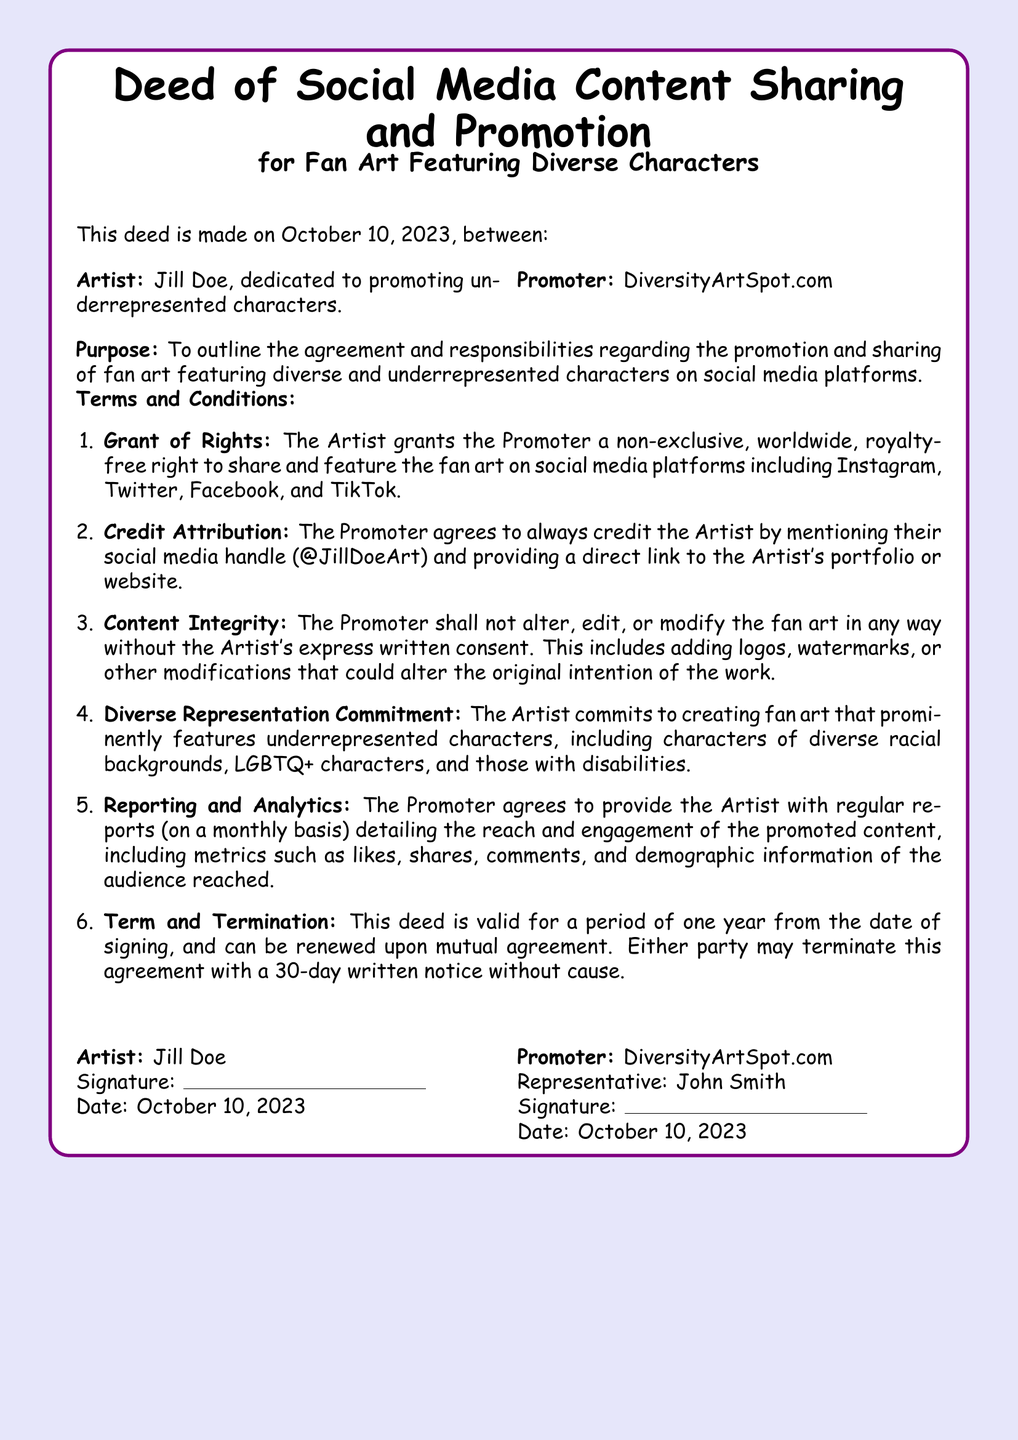What is the date of the deed? The date of the deed is mentioned at the beginning of the document, which is October 10, 2023.
Answer: October 10, 2023 Who is the artist? The artist's name is listed in the document, which is Jill Doe.
Answer: Jill Doe What is the purpose of the deed? The purpose of the deed is stated clearly in the document as outlining the agreement and responsibilities regarding the promotion and sharing of fan art.
Answer: To outline the agreement and responsibilities regarding the promotion and sharing of fan art featuring diverse and underrepresented characters What is the duration of the deed? The duration of the deed is specified as one year, as noted in the terms and conditions.
Answer: One year Who must be credited when the fan art is shared? The document specifies who must be credited and what social media handle to use for crediting.
Answer: Jill Doe, @JillDoeArt What commitment does the artist make regarding representation? This detail highlights the artist's obligation regarding the diverse representation in their artwork.
Answer: Creating fan art that prominently features underrepresented characters How often will the promoter provide reports? The document mentions the frequency of reporting provided by the promoter.
Answer: Monthly What is the name of the promoter? The promoter's name is specifically indicated in the document.
Answer: DiversityArtSpot.com 